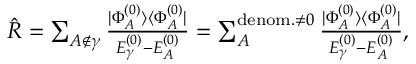Convert formula to latex. <formula><loc_0><loc_0><loc_500><loc_500>\begin{array} { r } { \hat { R } = \sum _ { A \notin \gamma } \frac { | \Phi _ { A } ^ { ( 0 ) } \rangle \langle \Phi _ { A } ^ { ( 0 ) } | } { E _ { \gamma } ^ { ( 0 ) } - E _ { A } ^ { ( 0 ) } } = \sum _ { A } ^ { d e n o m . \neq 0 } \frac { | \Phi _ { A } ^ { ( 0 ) } \rangle \langle \Phi _ { A } ^ { ( 0 ) } | } { E _ { \gamma } ^ { ( 0 ) } - E _ { A } ^ { ( 0 ) } } , } \end{array}</formula> 